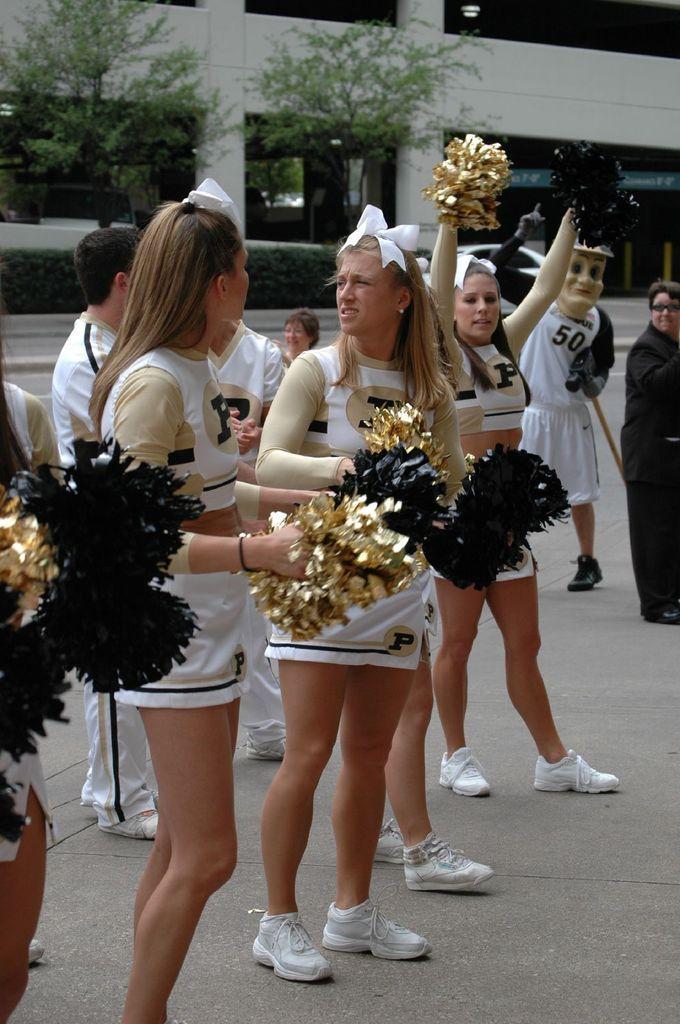Please provide a concise description of this image. In this image there are group of persons standing and in the background there are trees and there is a building which is white in colour. In front of the building there are plants. In the front there are women standing and holding an object which are black and golden colour. 